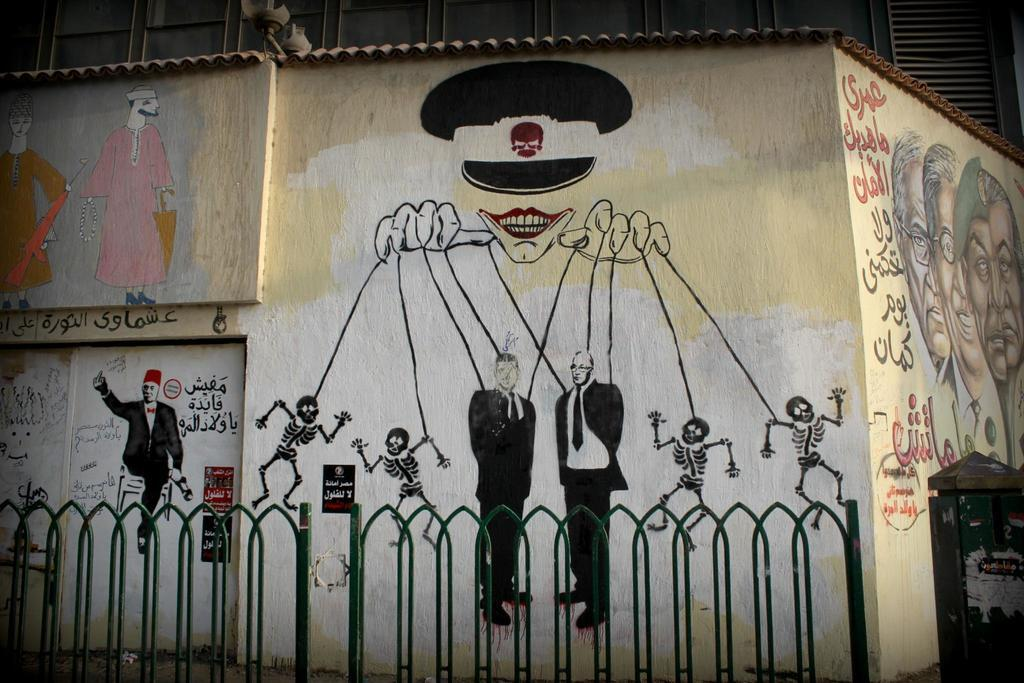What is located in the center of the image? There is a wall in the center of the image. What is on the wall? There is a painting on the wall. What can be seen in the foreground of the image? There is a fencing in the foreground. Where is the dustbin located in the image? The dustbin is in the bottom right corner of the image. How many quince are hanging from the fencing in the image? There are no quince present in the image; the fencing is the only item mentioned in the foreground. 